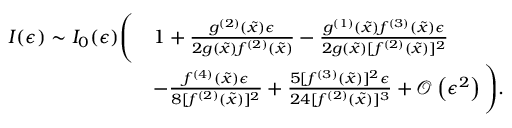<formula> <loc_0><loc_0><loc_500><loc_500>\begin{array} { r l } { I ( \epsilon ) \sim I _ { 0 } ( \epsilon ) \left ( } & { 1 + \frac { g ^ { ( 2 ) } ( \tilde { x } ) \epsilon } { 2 g ( \tilde { x } ) f ^ { ( 2 ) } ( \tilde { x } ) } - \frac { g ^ { ( 1 ) } ( \tilde { x } ) f ^ { ( 3 ) } ( \tilde { x } ) \epsilon } { 2 g ( \tilde { x } ) [ f ^ { ( 2 ) } ( \tilde { x } ) ] ^ { 2 } } } \\ & { - \frac { f ^ { ( 4 ) } ( \tilde { x } ) \epsilon } { 8 [ f ^ { ( 2 ) } ( \tilde { x } ) ] ^ { 2 } } + \frac { 5 [ f ^ { ( 3 ) } ( \tilde { x } ) ] ^ { 2 } \epsilon } { 2 4 [ f ^ { ( 2 ) } ( \tilde { x } ) ] ^ { 3 } } + \mathcal { O } \left ( \epsilon ^ { 2 } \right ) \right ) . } \end{array}</formula> 